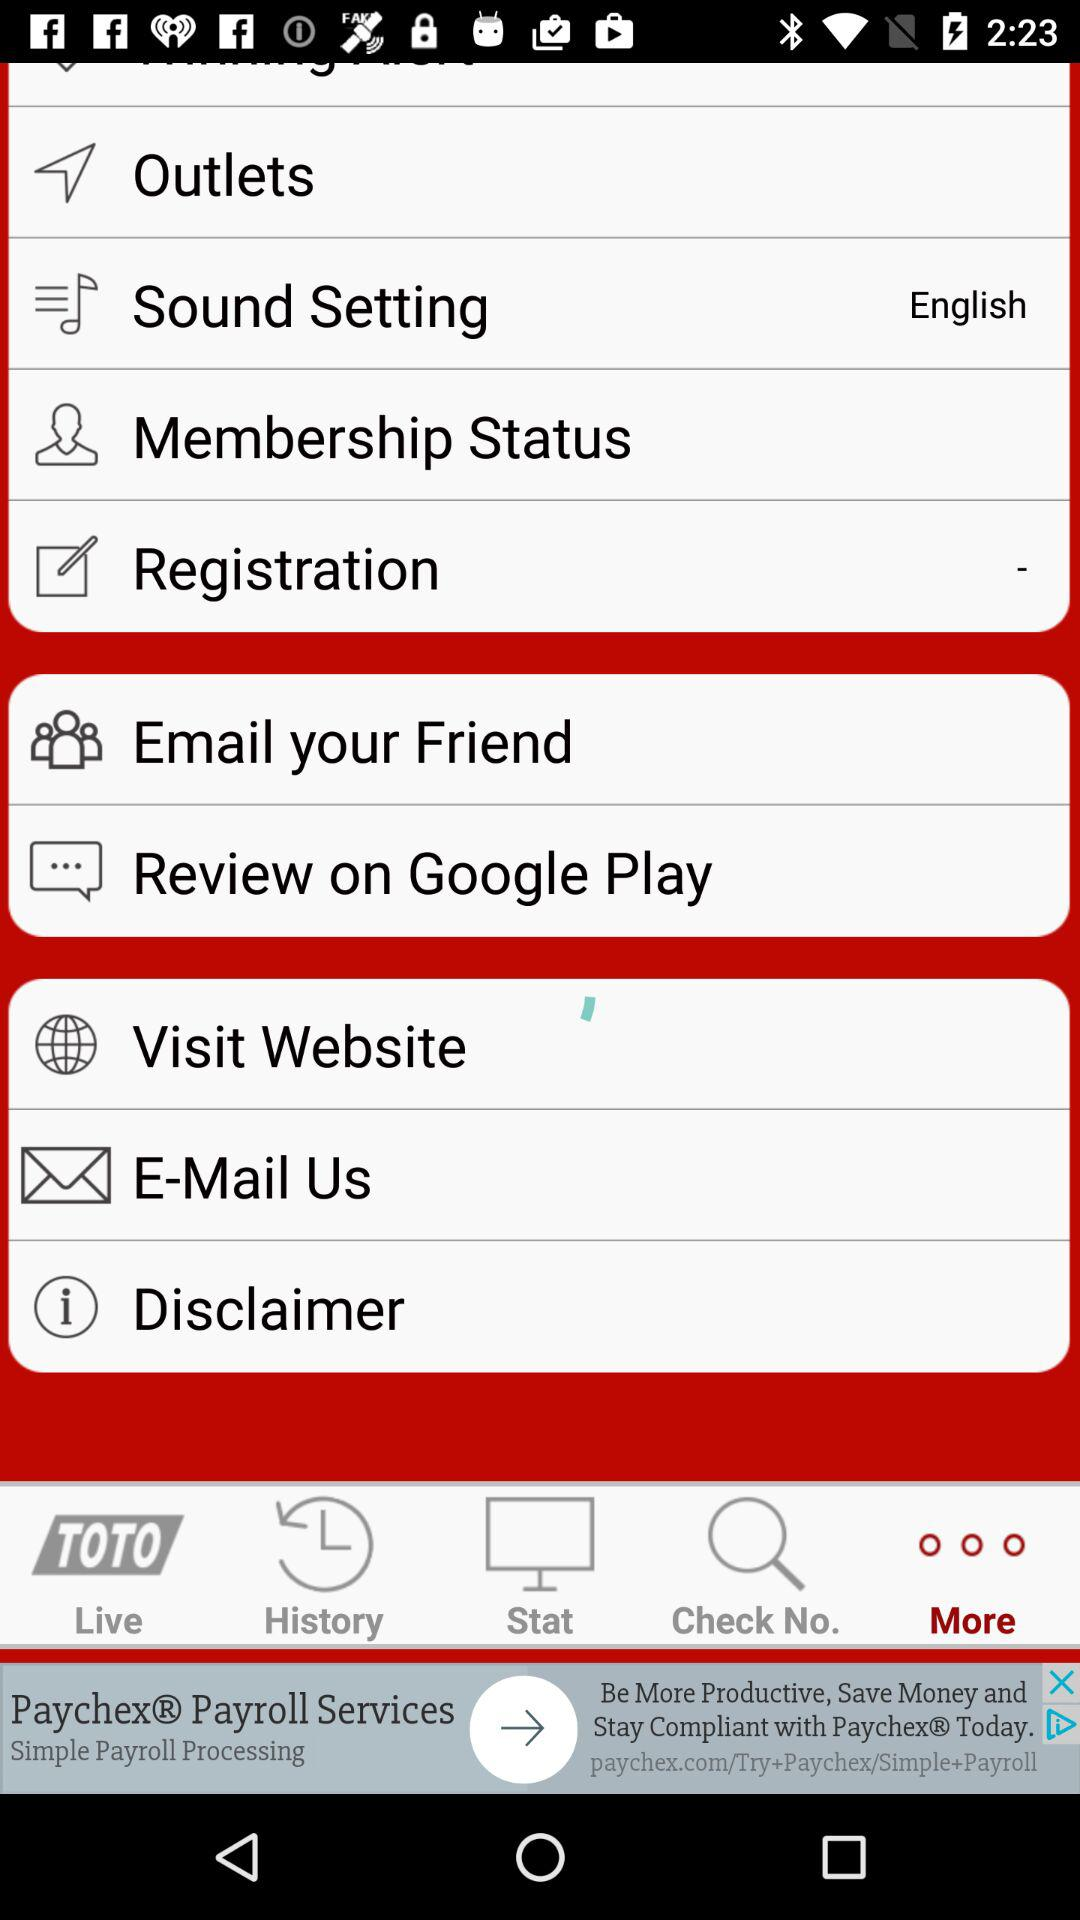Which language is selected in "Sound Setting"? The selected language in "Sound Setting" is English. 